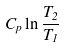<formula> <loc_0><loc_0><loc_500><loc_500>C _ { p } \ln \frac { T _ { 2 } } { T _ { 1 } }</formula> 